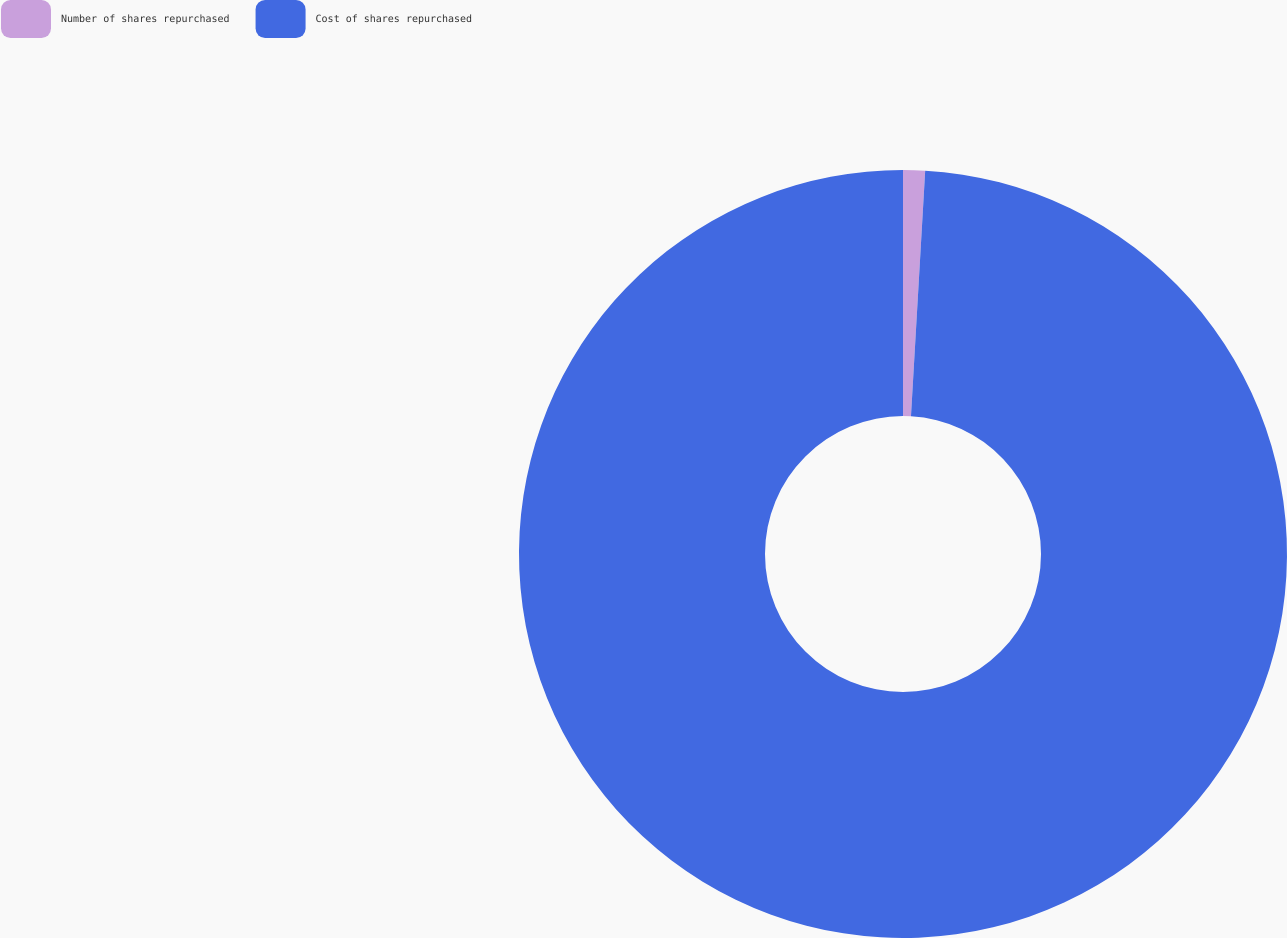<chart> <loc_0><loc_0><loc_500><loc_500><pie_chart><fcel>Number of shares repurchased<fcel>Cost of shares repurchased<nl><fcel>0.92%<fcel>99.08%<nl></chart> 